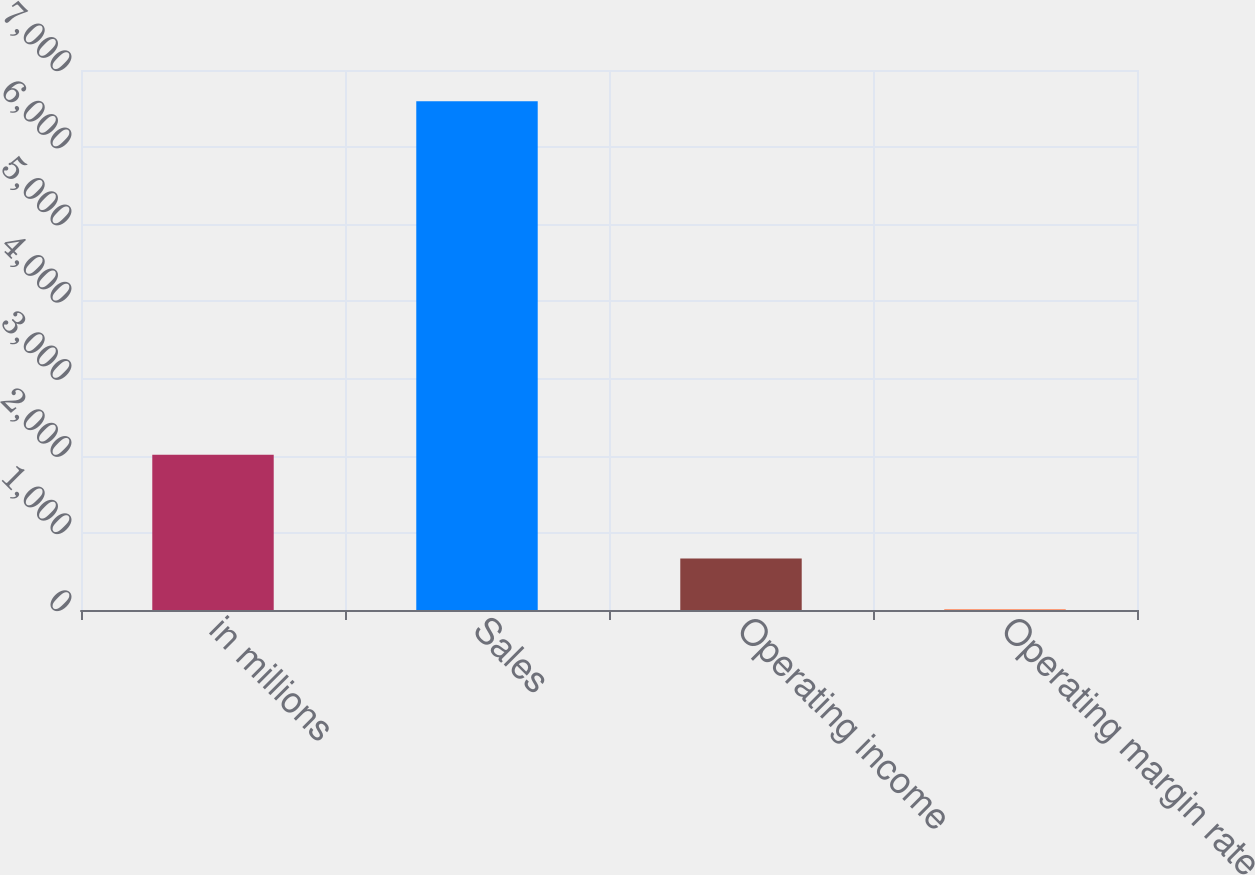Convert chart. <chart><loc_0><loc_0><loc_500><loc_500><bar_chart><fcel>in millions<fcel>Sales<fcel>Operating income<fcel>Operating margin rate<nl><fcel>2013<fcel>6596<fcel>668.24<fcel>9.6<nl></chart> 